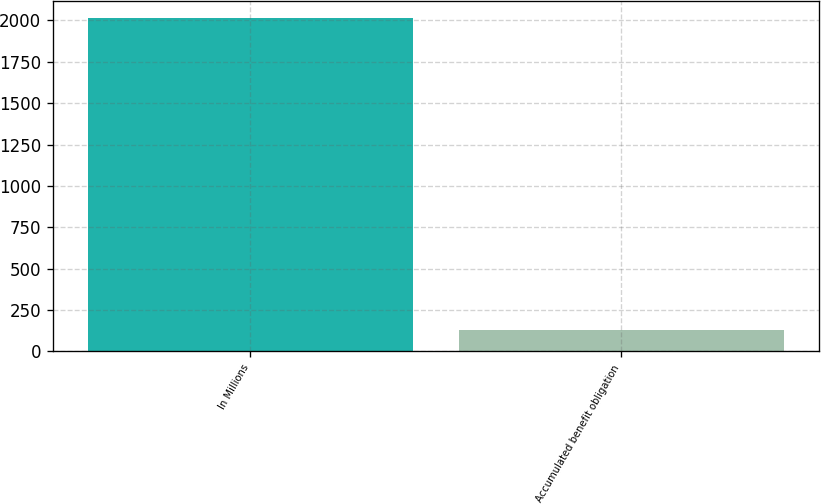Convert chart. <chart><loc_0><loc_0><loc_500><loc_500><bar_chart><fcel>In Millions<fcel>Accumulated benefit obligation<nl><fcel>2017<fcel>130.1<nl></chart> 